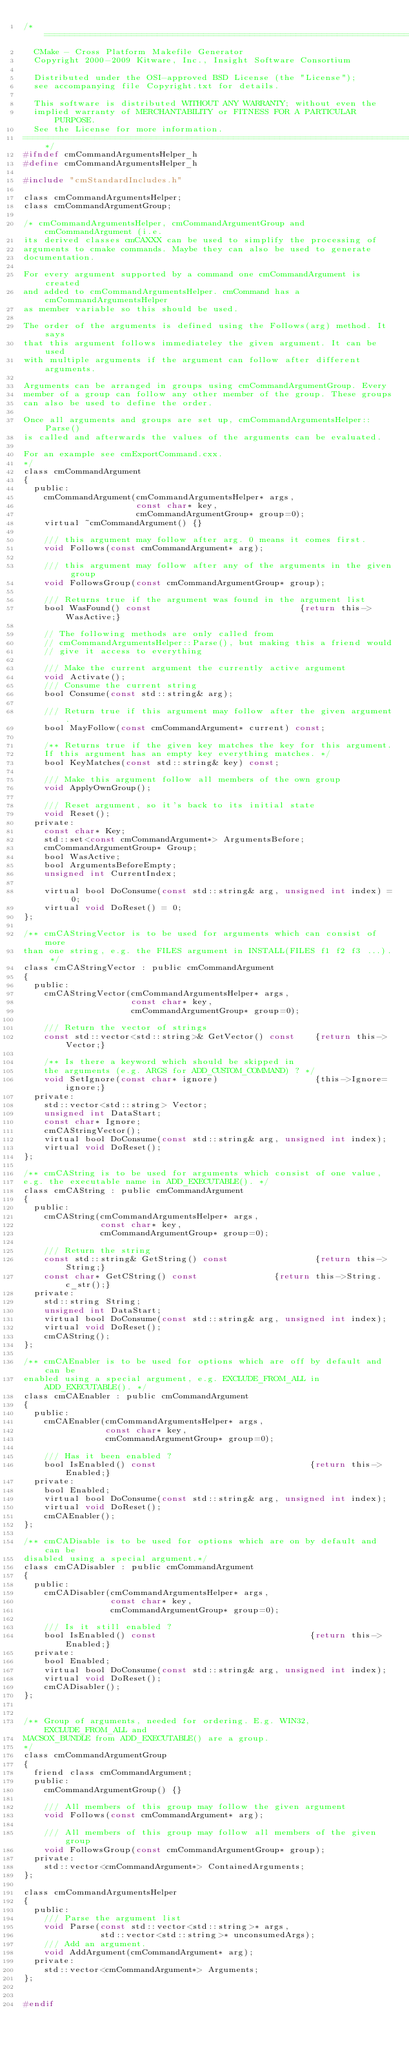Convert code to text. <code><loc_0><loc_0><loc_500><loc_500><_C_>/*============================================================================
  CMake - Cross Platform Makefile Generator
  Copyright 2000-2009 Kitware, Inc., Insight Software Consortium

  Distributed under the OSI-approved BSD License (the "License");
  see accompanying file Copyright.txt for details.

  This software is distributed WITHOUT ANY WARRANTY; without even the
  implied warranty of MERCHANTABILITY or FITNESS FOR A PARTICULAR PURPOSE.
  See the License for more information.
============================================================================*/
#ifndef cmCommandArgumentsHelper_h
#define cmCommandArgumentsHelper_h

#include "cmStandardIncludes.h"

class cmCommandArgumentsHelper;
class cmCommandArgumentGroup;

/* cmCommandArgumentsHelper, cmCommandArgumentGroup and cmCommandArgument (i.e.
its derived classes cmCAXXX can be used to simplify the processing of
arguments to cmake commands. Maybe they can also be used to generate
documentation.

For every argument supported by a command one cmCommandArgument is created
and added to cmCommandArgumentsHelper. cmCommand has a cmCommandArgumentsHelper
as member variable so this should be used.

The order of the arguments is defined using the Follows(arg) method. It says
that this argument follows immediateley the given argument. It can be used
with multiple arguments if the argument can follow after different arguments.

Arguments can be arranged in groups using cmCommandArgumentGroup. Every
member of a group can follow any other member of the group. These groups
can also be used to define the order.

Once all arguments and groups are set up, cmCommandArgumentsHelper::Parse()
is called and afterwards the values of the arguments can be evaluated.

For an example see cmExportCommand.cxx.
*/
class cmCommandArgument
{
  public:
    cmCommandArgument(cmCommandArgumentsHelper* args,
                      const char* key,
                      cmCommandArgumentGroup* group=0);
    virtual ~cmCommandArgument() {}

    /// this argument may follow after arg. 0 means it comes first.
    void Follows(const cmCommandArgument* arg);

    /// this argument may follow after any of the arguments in the given group
    void FollowsGroup(const cmCommandArgumentGroup* group);

    /// Returns true if the argument was found in the argument list
    bool WasFound() const                             {return this->WasActive;}

    // The following methods are only called from
    // cmCommandArgumentsHelper::Parse(), but making this a friend would
    // give it access to everything

    /// Make the current argument the currently active argument
    void Activate();
    /// Consume the current string
    bool Consume(const std::string& arg);

    /// Return true if this argument may follow after the given argument.
    bool MayFollow(const cmCommandArgument* current) const;

    /** Returns true if the given key matches the key for this argument.
    If this argument has an empty key everything matches. */
    bool KeyMatches(const std::string& key) const;

    /// Make this argument follow all members of the own group
    void ApplyOwnGroup();

    /// Reset argument, so it's back to its initial state
    void Reset();
  private:
    const char* Key;
    std::set<const cmCommandArgument*> ArgumentsBefore;
    cmCommandArgumentGroup* Group;
    bool WasActive;
    bool ArgumentsBeforeEmpty;
    unsigned int CurrentIndex;

    virtual bool DoConsume(const std::string& arg, unsigned int index) = 0;
    virtual void DoReset() = 0;
};

/** cmCAStringVector is to be used for arguments which can consist of more
than one string, e.g. the FILES argument in INSTALL(FILES f1 f2 f3 ...). */
class cmCAStringVector : public cmCommandArgument
{
  public:
    cmCAStringVector(cmCommandArgumentsHelper* args,
                     const char* key,
                     cmCommandArgumentGroup* group=0);

    /// Return the vector of strings
    const std::vector<std::string>& GetVector() const    {return this->Vector;}

    /** Is there a keyword which should be skipped in
    the arguments (e.g. ARGS for ADD_CUSTOM_COMMAND) ? */
    void SetIgnore(const char* ignore)                   {this->Ignore=ignore;}
  private:
    std::vector<std::string> Vector;
    unsigned int DataStart;
    const char* Ignore;
    cmCAStringVector();
    virtual bool DoConsume(const std::string& arg, unsigned int index);
    virtual void DoReset();
};

/** cmCAString is to be used for arguments which consist of one value,
e.g. the executable name in ADD_EXECUTABLE(). */
class cmCAString : public cmCommandArgument
{
  public:
    cmCAString(cmCommandArgumentsHelper* args,
               const char* key,
               cmCommandArgumentGroup* group=0);

    /// Return the string
    const std::string& GetString() const                 {return this->String;}
    const char* GetCString() const               {return this->String.c_str();}
  private:
    std::string String;
    unsigned int DataStart;
    virtual bool DoConsume(const std::string& arg, unsigned int index);
    virtual void DoReset();
    cmCAString();
};

/** cmCAEnabler is to be used for options which are off by default and can be
enabled using a special argument, e.g. EXCLUDE_FROM_ALL in ADD_EXECUTABLE(). */
class cmCAEnabler : public cmCommandArgument
{
  public:
    cmCAEnabler(cmCommandArgumentsHelper* args,
                const char* key,
                cmCommandArgumentGroup* group=0);

    /// Has it been enabled ?
    bool IsEnabled() const                              {return this->Enabled;}
  private:
    bool Enabled;
    virtual bool DoConsume(const std::string& arg, unsigned int index);
    virtual void DoReset();
    cmCAEnabler();
};

/** cmCADisable is to be used for options which are on by default and can be
disabled using a special argument.*/
class cmCADisabler : public cmCommandArgument
{
  public:
    cmCADisabler(cmCommandArgumentsHelper* args,
                 const char* key,
                 cmCommandArgumentGroup* group=0);

    /// Is it still enabled ?
    bool IsEnabled() const                              {return this->Enabled;}
  private:
    bool Enabled;
    virtual bool DoConsume(const std::string& arg, unsigned int index);
    virtual void DoReset();
    cmCADisabler();
};


/** Group of arguments, needed for ordering. E.g. WIN32, EXCLUDE_FROM_ALL and
MACSOX_BUNDLE from ADD_EXECUTABLE() are a group.
*/
class cmCommandArgumentGroup
{
  friend class cmCommandArgument;
  public:
    cmCommandArgumentGroup() {}

    /// All members of this group may follow the given argument
    void Follows(const cmCommandArgument* arg);

    /// All members of this group may follow all members of the given group
    void FollowsGroup(const cmCommandArgumentGroup* group);
  private:
    std::vector<cmCommandArgument*> ContainedArguments;
};

class cmCommandArgumentsHelper
{
  public:
    /// Parse the argument list
    void Parse(const std::vector<std::string>* args,
               std::vector<std::string>* unconsumedArgs);
    /// Add an argument.
    void AddArgument(cmCommandArgument* arg);
  private:
    std::vector<cmCommandArgument*> Arguments;
};


#endif
</code> 